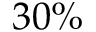Convert formula to latex. <formula><loc_0><loc_0><loc_500><loc_500>3 0 \%</formula> 